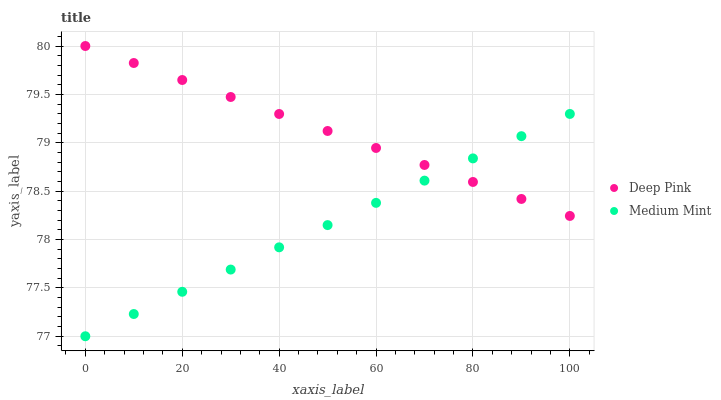Does Medium Mint have the minimum area under the curve?
Answer yes or no. Yes. Does Deep Pink have the maximum area under the curve?
Answer yes or no. Yes. Does Deep Pink have the minimum area under the curve?
Answer yes or no. No. Is Deep Pink the smoothest?
Answer yes or no. Yes. Is Medium Mint the roughest?
Answer yes or no. Yes. Is Deep Pink the roughest?
Answer yes or no. No. Does Medium Mint have the lowest value?
Answer yes or no. Yes. Does Deep Pink have the lowest value?
Answer yes or no. No. Does Deep Pink have the highest value?
Answer yes or no. Yes. Does Deep Pink intersect Medium Mint?
Answer yes or no. Yes. Is Deep Pink less than Medium Mint?
Answer yes or no. No. Is Deep Pink greater than Medium Mint?
Answer yes or no. No. 